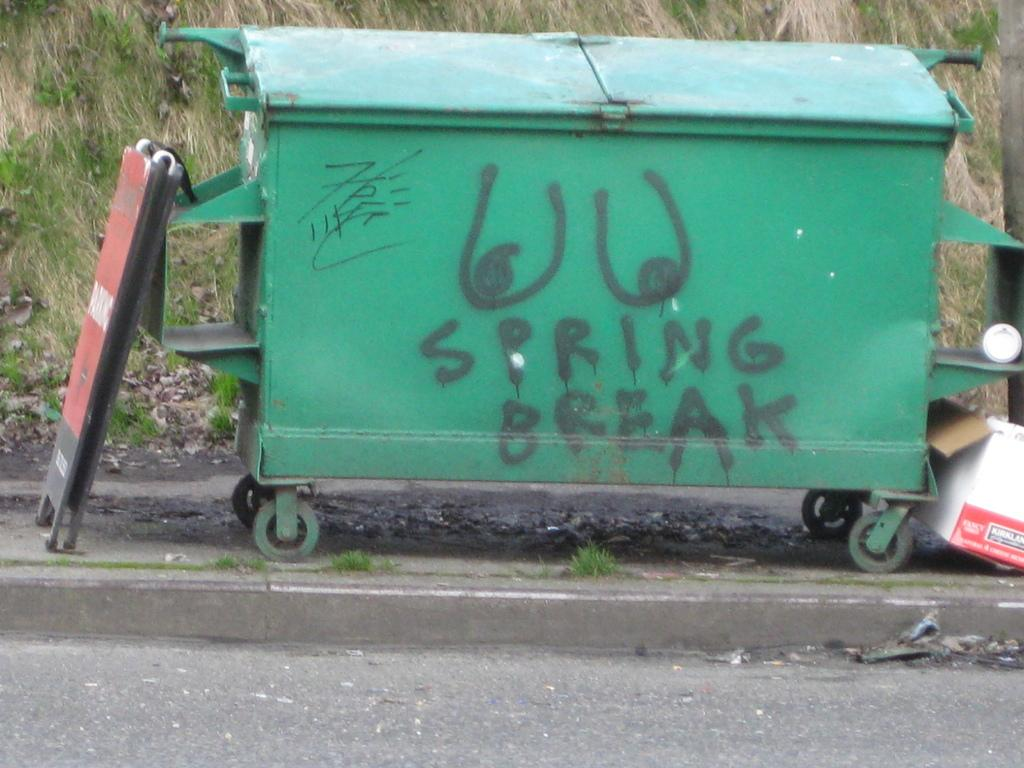<image>
Give a short and clear explanation of the subsequent image. A green dumpster has spring break spray painted on it in black. 